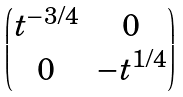<formula> <loc_0><loc_0><loc_500><loc_500>\begin{pmatrix} t ^ { - 3 / 4 } & 0 \\ 0 & - t ^ { 1 / 4 } \end{pmatrix}</formula> 